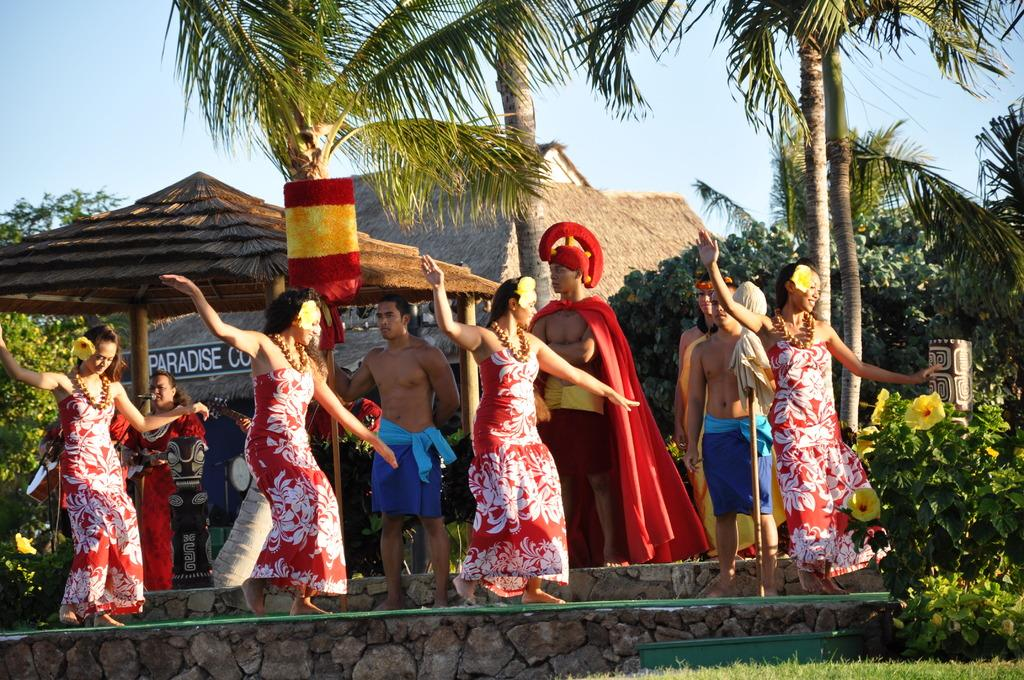What are the ladies in the image doing? The ladies in the image are walking on a rope. What can be seen in the background of the image? There are trees, huts, plants, and other people in the background of the image. What type of development can be seen in the image? There is no specific development visible in the image; it primarily features ladies walking on a rope and the background elements. 